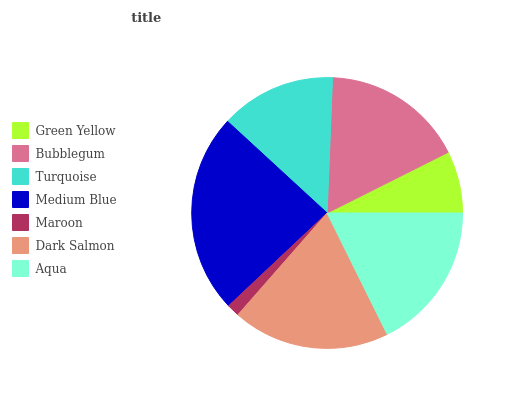Is Maroon the minimum?
Answer yes or no. Yes. Is Medium Blue the maximum?
Answer yes or no. Yes. Is Bubblegum the minimum?
Answer yes or no. No. Is Bubblegum the maximum?
Answer yes or no. No. Is Bubblegum greater than Green Yellow?
Answer yes or no. Yes. Is Green Yellow less than Bubblegum?
Answer yes or no. Yes. Is Green Yellow greater than Bubblegum?
Answer yes or no. No. Is Bubblegum less than Green Yellow?
Answer yes or no. No. Is Bubblegum the high median?
Answer yes or no. Yes. Is Bubblegum the low median?
Answer yes or no. Yes. Is Turquoise the high median?
Answer yes or no. No. Is Turquoise the low median?
Answer yes or no. No. 